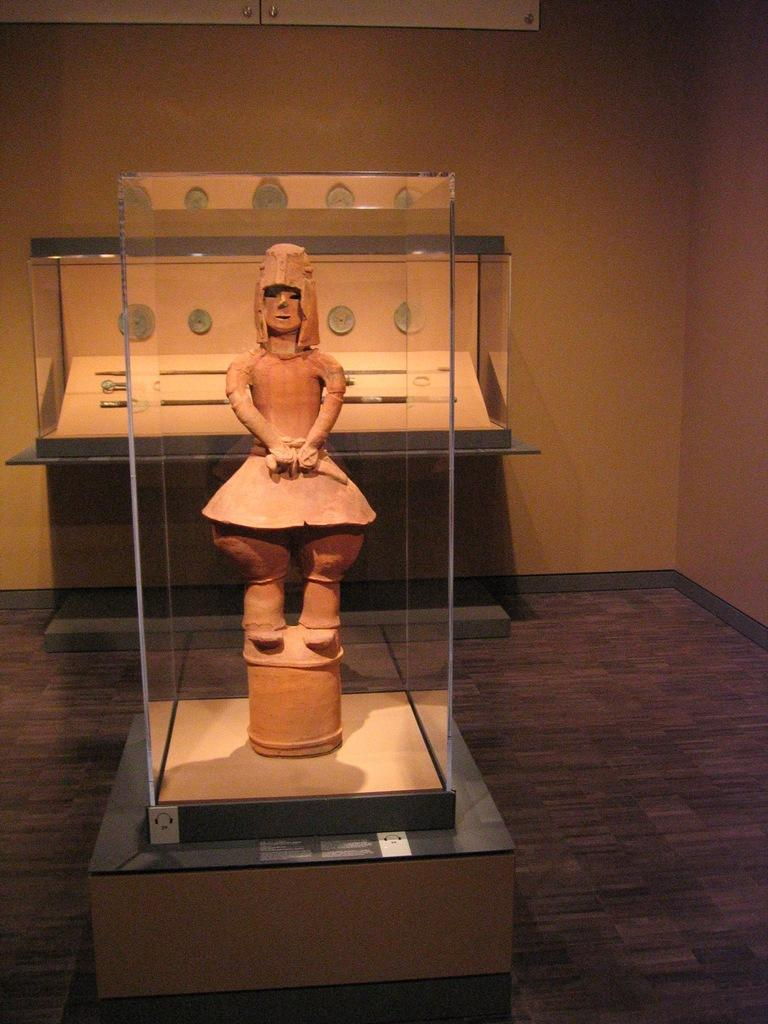What object is present in the image that can hold a liquid? There is a glass in the image. What can be seen through the glass in the image? A statue is visible through the glass. What is located in the background of the image? There are clocks and a wall in the background of the image. What type of mailbox is present in the image? There is no mailbox present in the image. What kind of relation does the statue have with the clocks in the image? The image does not depict a relationship between the statue and the clocks; they are simply separate elements in the background. 